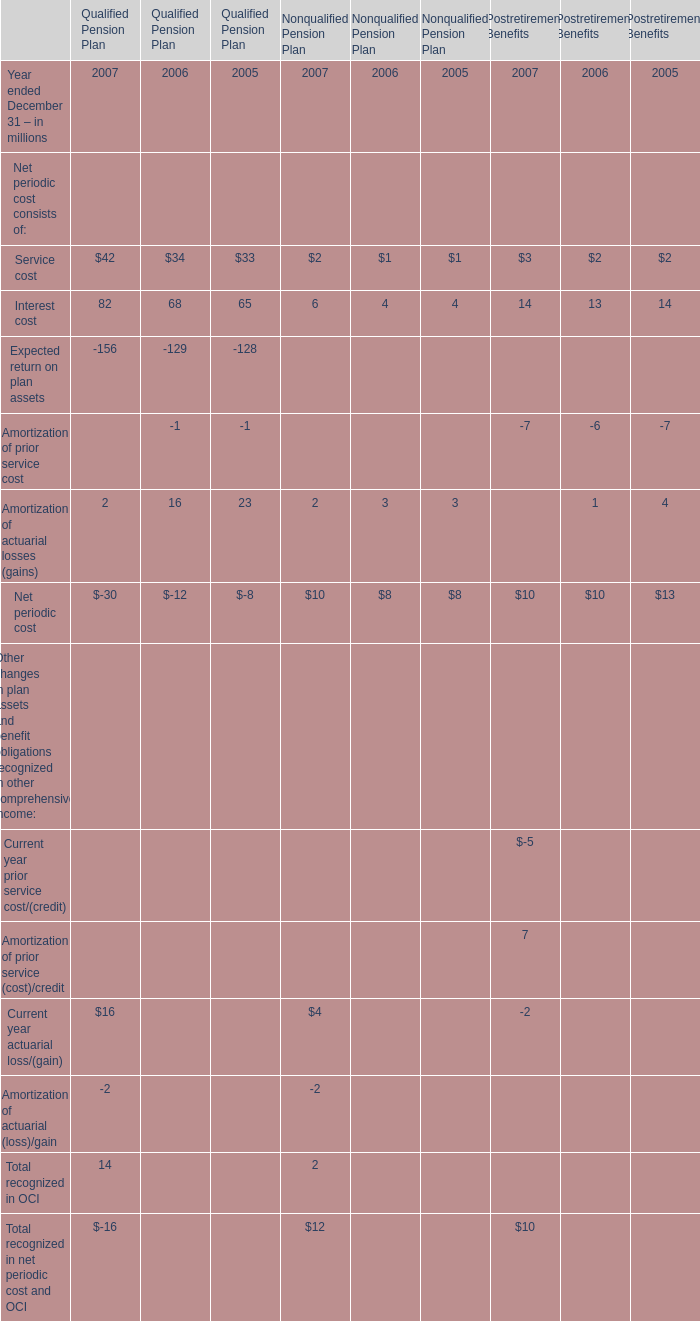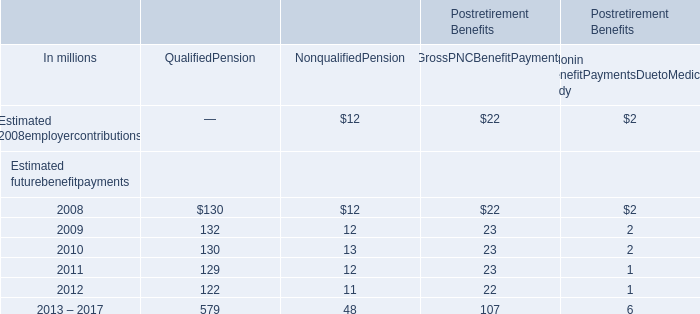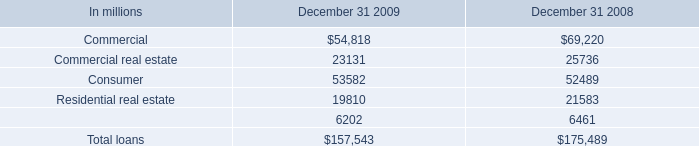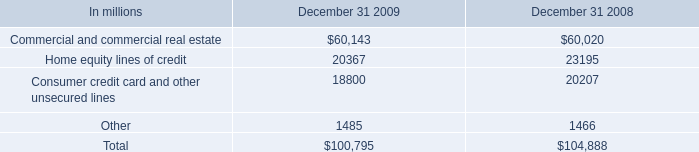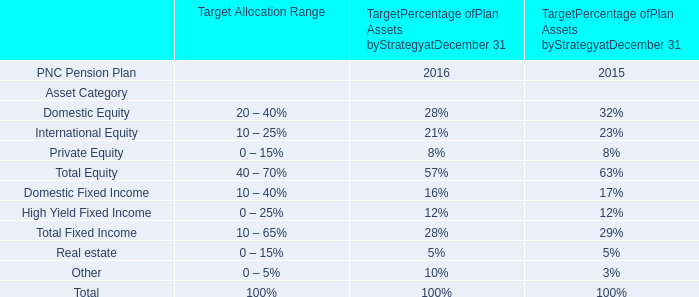What's the growth rate of Interest cost for Qualified Pension Plan in 2007? 
Computations: ((82 - 68) / 68)
Answer: 0.20588. 